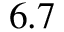Convert formula to latex. <formula><loc_0><loc_0><loc_500><loc_500>6 . 7</formula> 